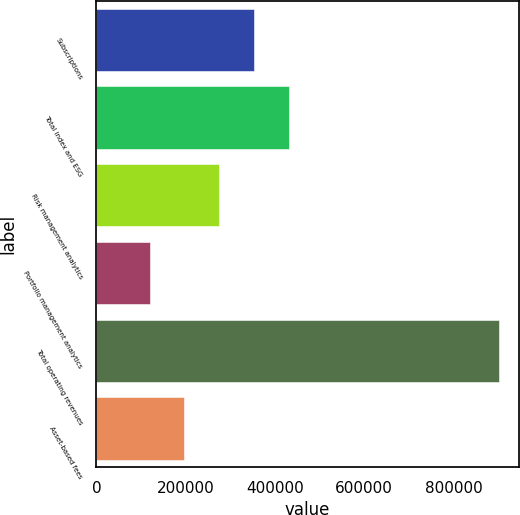Convert chart. <chart><loc_0><loc_0><loc_500><loc_500><bar_chart><fcel>Subscriptions<fcel>Total index and ESG<fcel>Risk management analytics<fcel>Portfolio management analytics<fcel>Total operating revenues<fcel>Asset-based fees<nl><fcel>353505<fcel>431710<fcel>275299<fcel>118889<fcel>900941<fcel>197094<nl></chart> 